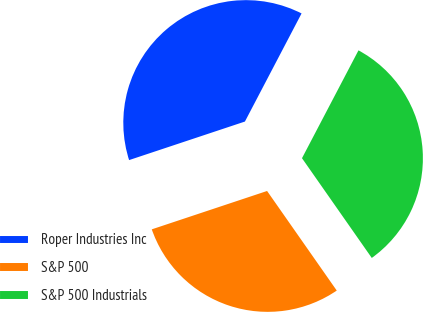Convert chart to OTSL. <chart><loc_0><loc_0><loc_500><loc_500><pie_chart><fcel>Roper Industries Inc<fcel>S&P 500<fcel>S&P 500 Industrials<nl><fcel>37.79%<fcel>29.6%<fcel>32.6%<nl></chart> 